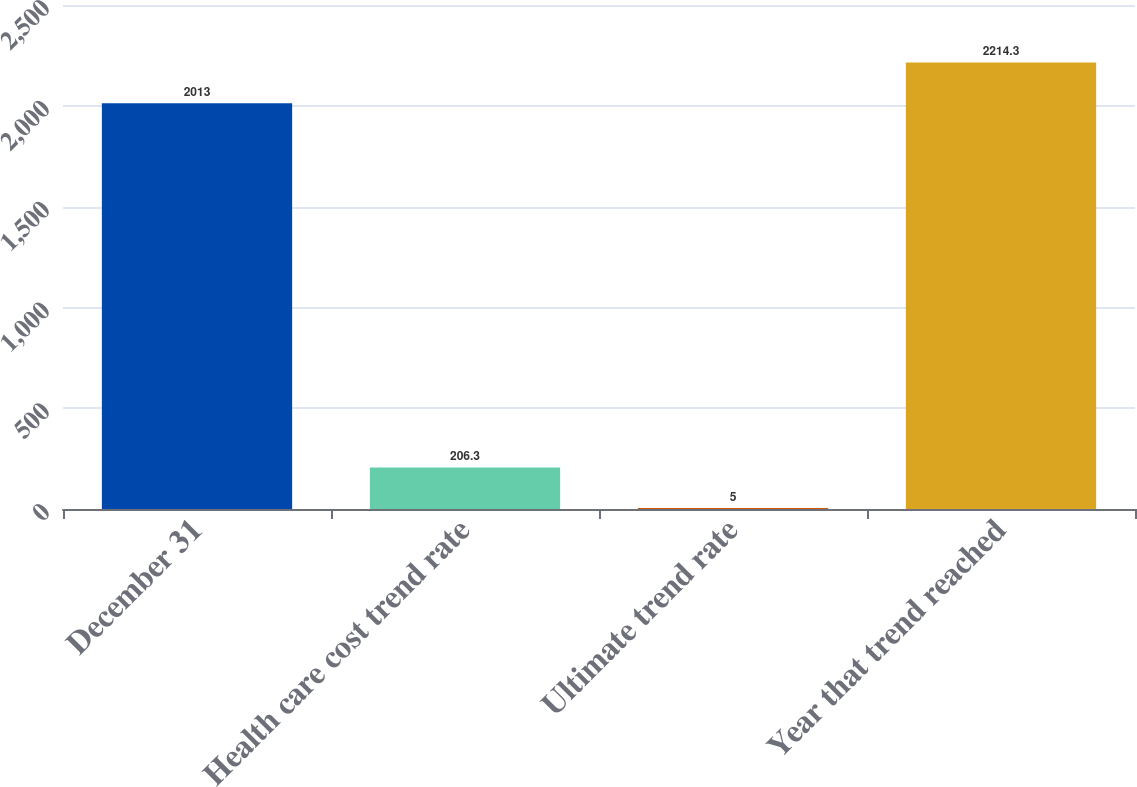Convert chart to OTSL. <chart><loc_0><loc_0><loc_500><loc_500><bar_chart><fcel>December 31<fcel>Health care cost trend rate<fcel>Ultimate trend rate<fcel>Year that trend reached<nl><fcel>2013<fcel>206.3<fcel>5<fcel>2214.3<nl></chart> 